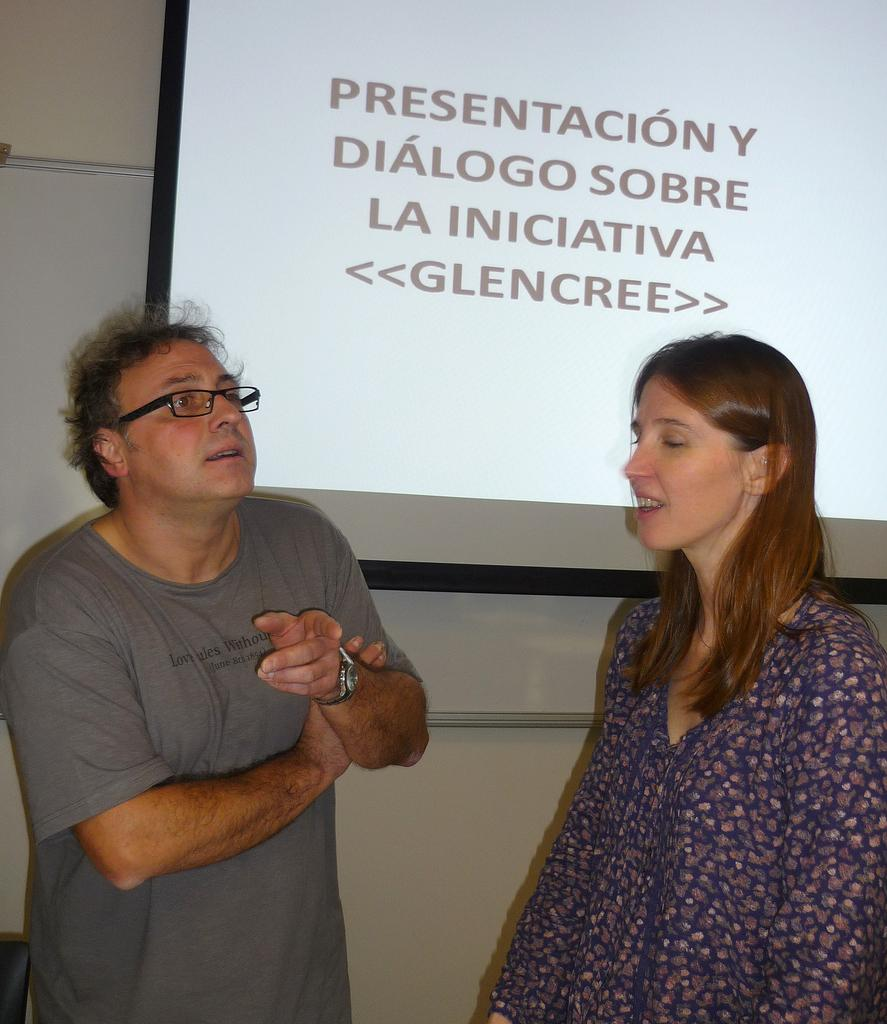How many people are in the image? There are two people in the image, a man and a woman. What are the man and woman doing in the image? The man and woman are standing. What can be seen in the background of the image? There is a screen, a wall, and a board in the background of the image. What type of wood is the heart made of in the image? There is no heart or wood present in the image. What is the minister's role in the image? There is no minister present in the image. 